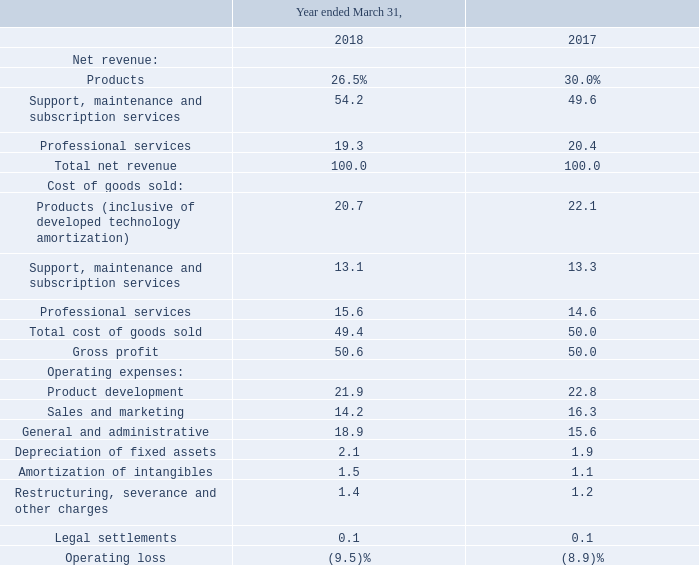The following table presents the percentage relationship of our Consolidated Statement of Operations line items to our consolidated net revenues for the periods presented:
Net revenue. Total revenue decreased $0.3 million, or 0.2% in fiscal 2018 compared to fiscal 2017. Products revenue decreased $4.6 million or 12.1% while support, maintenance and subscription services revenue increased 5.8 million, or 9.1%, as a result of continued focus on selling hosted perpetual and subscription services which increased 35% year over year. Hosted perpetual and subscription services revenue comprised 16% of total consolidated revenues in 2018 compared to 12% in 2017. Professional services revenue decreased $1.4 million, or 5.5%, primarily as a result of a decrease in proprietary services of $1.5 million offset by an increase in remarketed services of $0.1 million.
Gross profit and gross profit margin. Our total gross profit increased $0.6 million, or 1.0%, in fiscal 2018 and total gross profit margin increased 0.6% to 50.6%. Products gross profit decreased $2.8 million and gross profit margin decreased 4.6% to 21.7% primarily as a result of lower product revenue coupled with higher amortization of developed technology by $2.0 million related to the previously announced general availability of the latest version of our rGuest Buy and rGuest Stay software that were placed into service in the first and second quarters of fiscal 2017, and the second quarter of fiscal 2018.
Support, maintenance and subscription services gross profit increased $6.0 million and gross profit margin increased 260 basis points to 75.8% due to the scalable nature of our infrastructure supporting and hosting customers. Professional services gross profit decreased $2.6 million and gross profit margin decreased 9.0% to 19.2% due to lower professional services revenues on higher cost structure following a recent alignment toward enabling the Company to provide more customer-centric services going forward.
Operating expenses Operating expenses, excluding legal settlements and restructuring, severance and other charges, increased $1.0 million, or 1.4%, in fiscal 2018 compared with fiscal 2017. As a percent of total revenue, operating expenses have increased 0.9% in fiscal 2018 compared with fiscal 2017
Product development. Product development includes all expenses associated with research and development. Product development decreased $1.1 million, or 3.8%, during fiscal 2018 as compared to fiscal 2017. This decrease is primarily driven by our shift from contract labor to internal resources resulting in a decrease in contract labor of $5.9 million and an increase in payroll related expenses of $4.7 million.
Sales and marketing. Sales and marketing decreased $2.7 million, or 13.2%, in fiscal 2018 compared with fiscal 2017. The change is due primarily to a decrease of $2.2 million in incentive commissions related to revision of our commission plan from total contract value to annual contract value coupled with lower sales in fiscal 2018.
Depreciation of fixed assets. Depreciation of fixed assets increased $0.2 million or 9.2% in fiscal 2018 as compared to fiscal 2017.
Amortization of intangibles. Amortization of intangibles increased $0.5 million, or 35.0%, in fiscal 2018 as compared to fiscal 2017 due to our latest version of rGuest Pay being placed into service on March 31, 2017.
Restructuring, severance and other charges. Restructuring, severance, and other charges increased $0.2 million during fiscal 2018 compared to fiscal 2017 related to our ongoing efforts to create more efficient teams across the business, which included certain executive changes during the year.
Our restructuring actions are discussed further in Note 4, Restructuring Charges.
Legal settlements. During fiscal 2018 and 2017, we recorded $0.2 million and $0.1 million, respectively, in legal settlements for employment and other business-related matters.
What was the decrease in total revenue? $0.3 million, or 0.2%. What was the decrease in Professional services revenue? $1.4 million, or 5.5%. What was the increase in gross profit margin? $0.6 million, or 1.0%. What was the increase / (decrease) in the percentage of Professional services of net revenue from 2017 to 2018?
Answer scale should be: percent. 19.3 - 20.4
Answer: -1.1. What was total gross profit in 2017?
Answer scale should be: million. 0.6/1.0*100
Answer: 60. What was total gross profit in 2018?
Answer scale should be: million. 0.6/1.0*100+0.6
Answer: 60.6. 